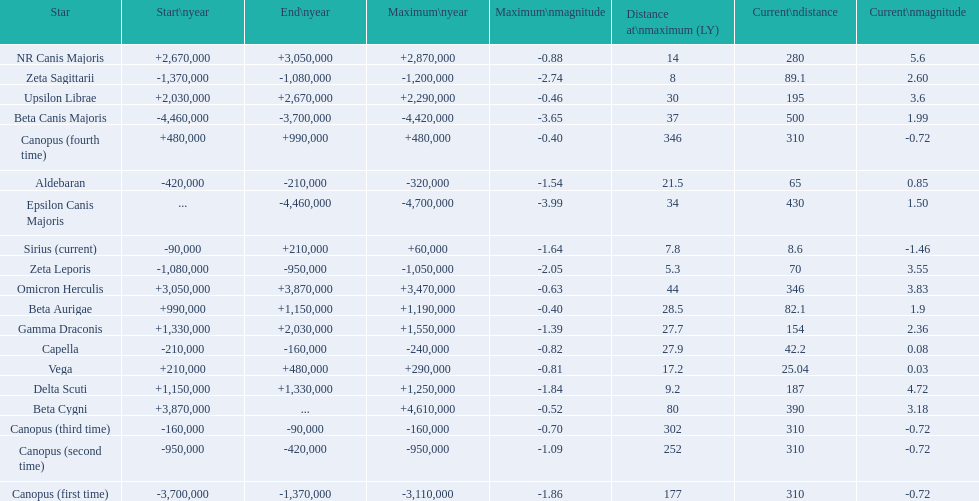What star has a a maximum magnitude of -0.63. Omicron Herculis. What star has a current distance of 390? Beta Cygni. 